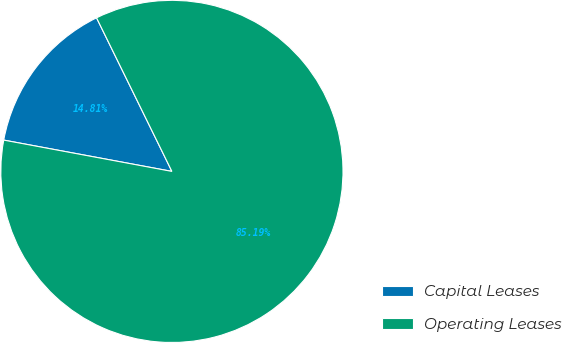<chart> <loc_0><loc_0><loc_500><loc_500><pie_chart><fcel>Capital Leases<fcel>Operating Leases<nl><fcel>14.81%<fcel>85.19%<nl></chart> 